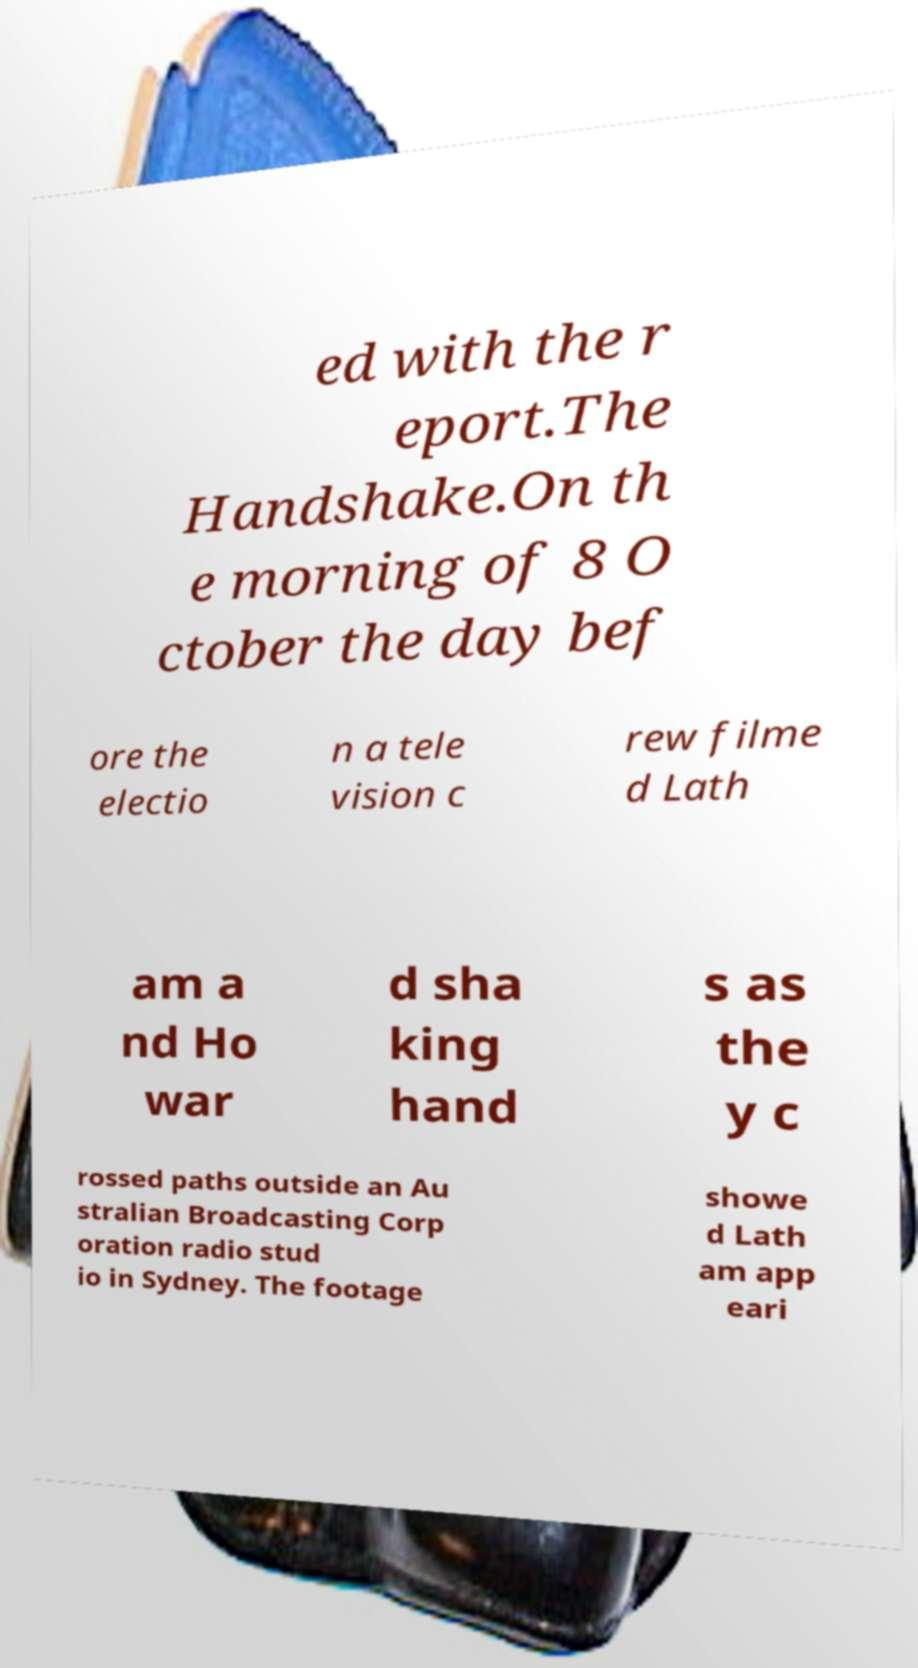For documentation purposes, I need the text within this image transcribed. Could you provide that? ed with the r eport.The Handshake.On th e morning of 8 O ctober the day bef ore the electio n a tele vision c rew filme d Lath am a nd Ho war d sha king hand s as the y c rossed paths outside an Au stralian Broadcasting Corp oration radio stud io in Sydney. The footage showe d Lath am app eari 